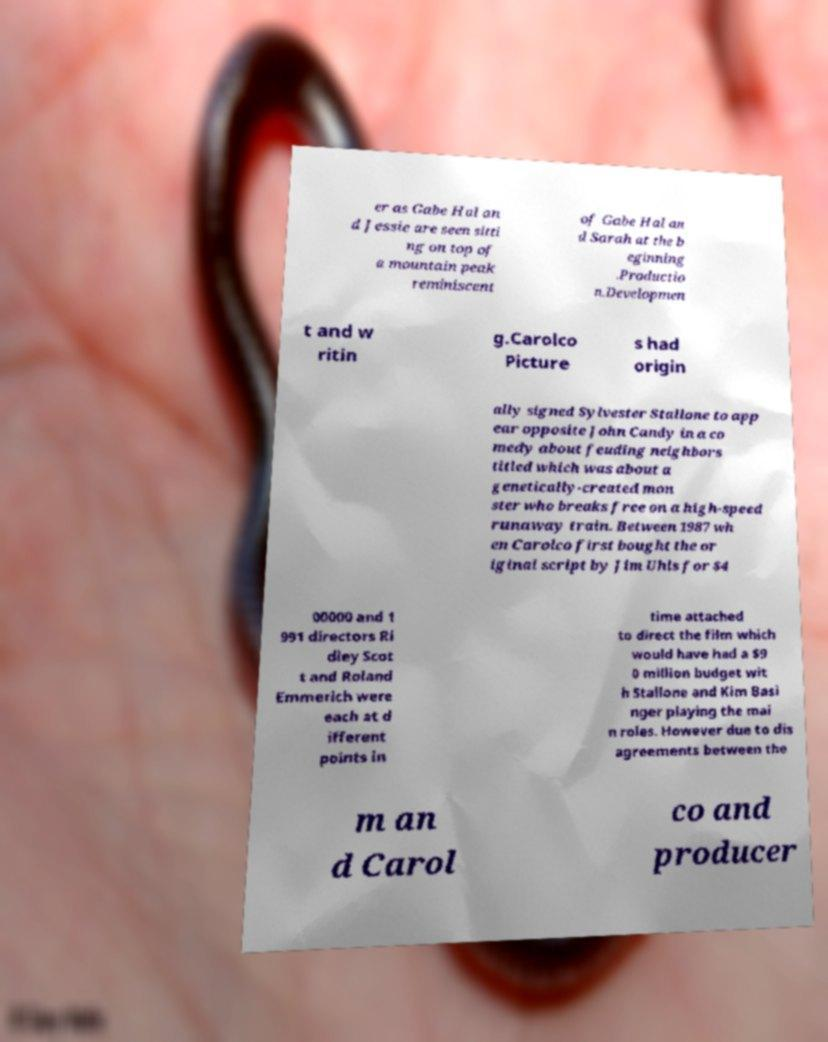There's text embedded in this image that I need extracted. Can you transcribe it verbatim? er as Gabe Hal an d Jessie are seen sitti ng on top of a mountain peak reminiscent of Gabe Hal an d Sarah at the b eginning .Productio n.Developmen t and w ritin g.Carolco Picture s had origin ally signed Sylvester Stallone to app ear opposite John Candy in a co medy about feuding neighbors titled which was about a genetically-created mon ster who breaks free on a high-speed runaway train. Between 1987 wh en Carolco first bought the or iginal script by Jim Uhls for $4 00000 and 1 991 directors Ri dley Scot t and Roland Emmerich were each at d ifferent points in time attached to direct the film which would have had a $9 0 million budget wit h Stallone and Kim Basi nger playing the mai n roles. However due to dis agreements between the m an d Carol co and producer 